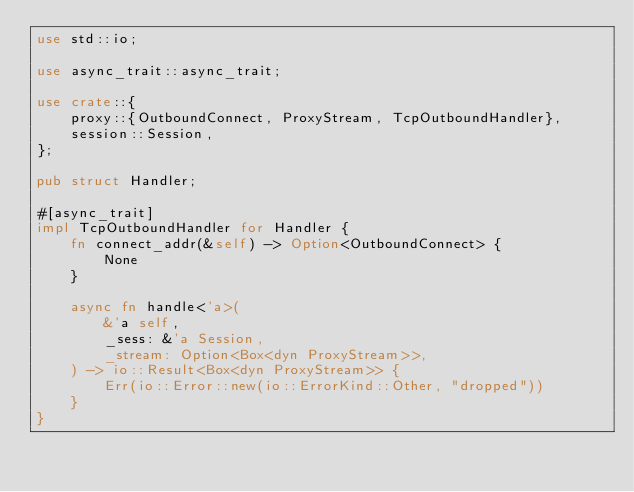Convert code to text. <code><loc_0><loc_0><loc_500><loc_500><_Rust_>use std::io;

use async_trait::async_trait;

use crate::{
    proxy::{OutboundConnect, ProxyStream, TcpOutboundHandler},
    session::Session,
};

pub struct Handler;

#[async_trait]
impl TcpOutboundHandler for Handler {
    fn connect_addr(&self) -> Option<OutboundConnect> {
        None
    }

    async fn handle<'a>(
        &'a self,
        _sess: &'a Session,
        _stream: Option<Box<dyn ProxyStream>>,
    ) -> io::Result<Box<dyn ProxyStream>> {
        Err(io::Error::new(io::ErrorKind::Other, "dropped"))
    }
}
</code> 